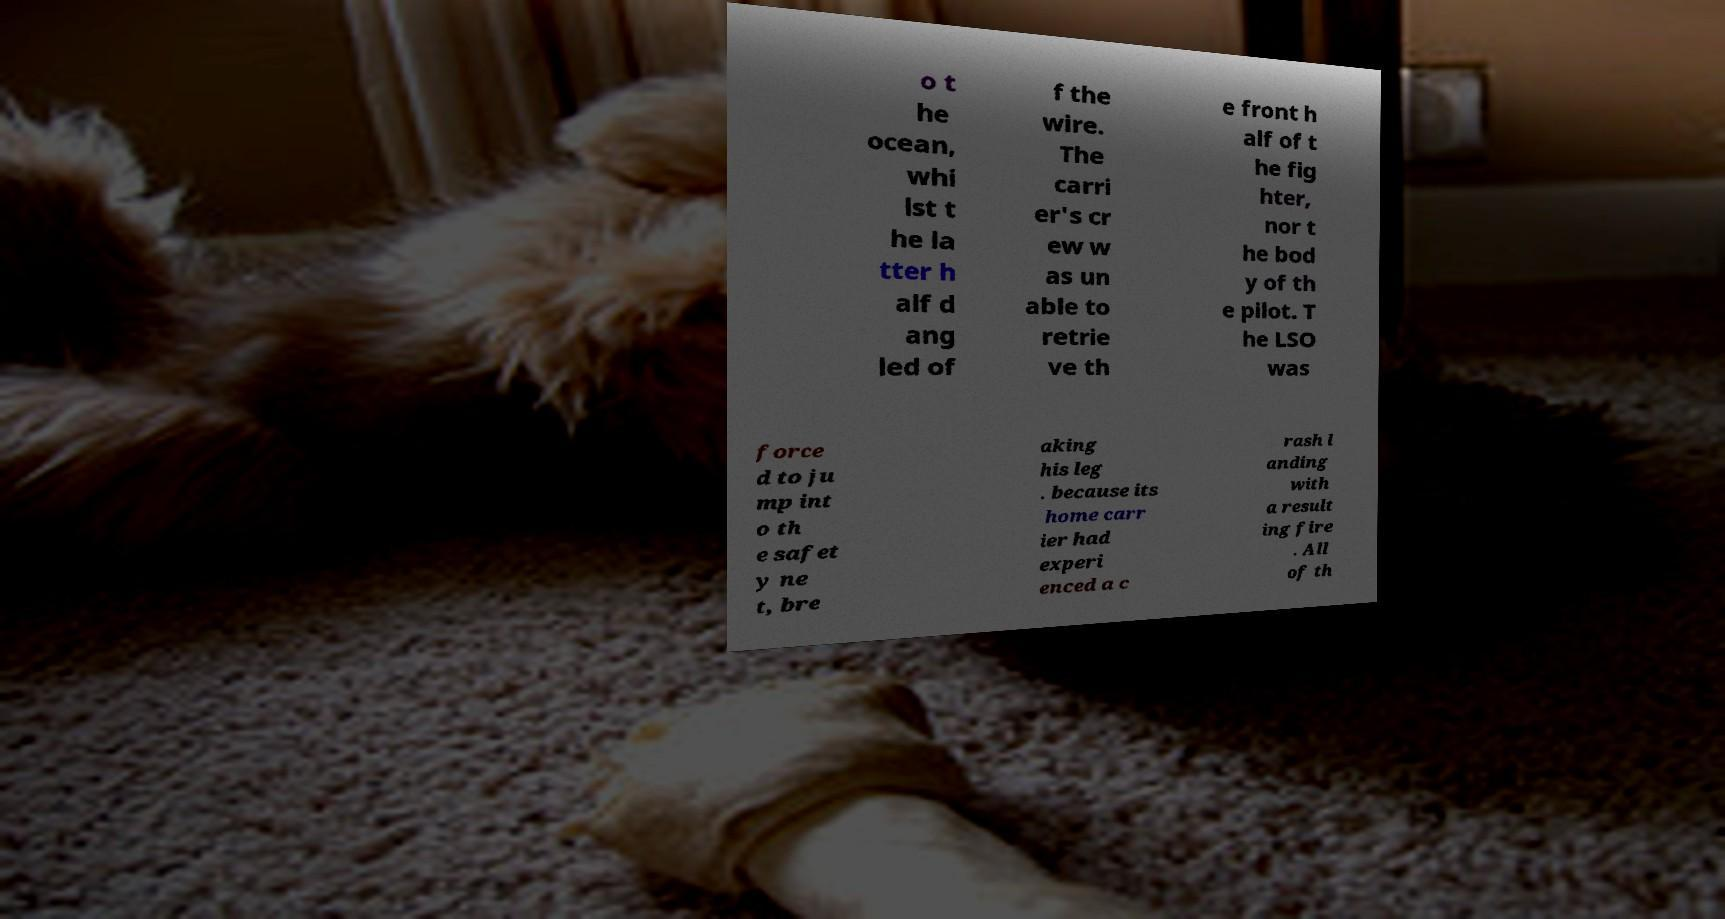What messages or text are displayed in this image? I need them in a readable, typed format. o t he ocean, whi lst t he la tter h alf d ang led of f the wire. The carri er's cr ew w as un able to retrie ve th e front h alf of t he fig hter, nor t he bod y of th e pilot. T he LSO was force d to ju mp int o th e safet y ne t, bre aking his leg . because its home carr ier had experi enced a c rash l anding with a result ing fire . All of th 